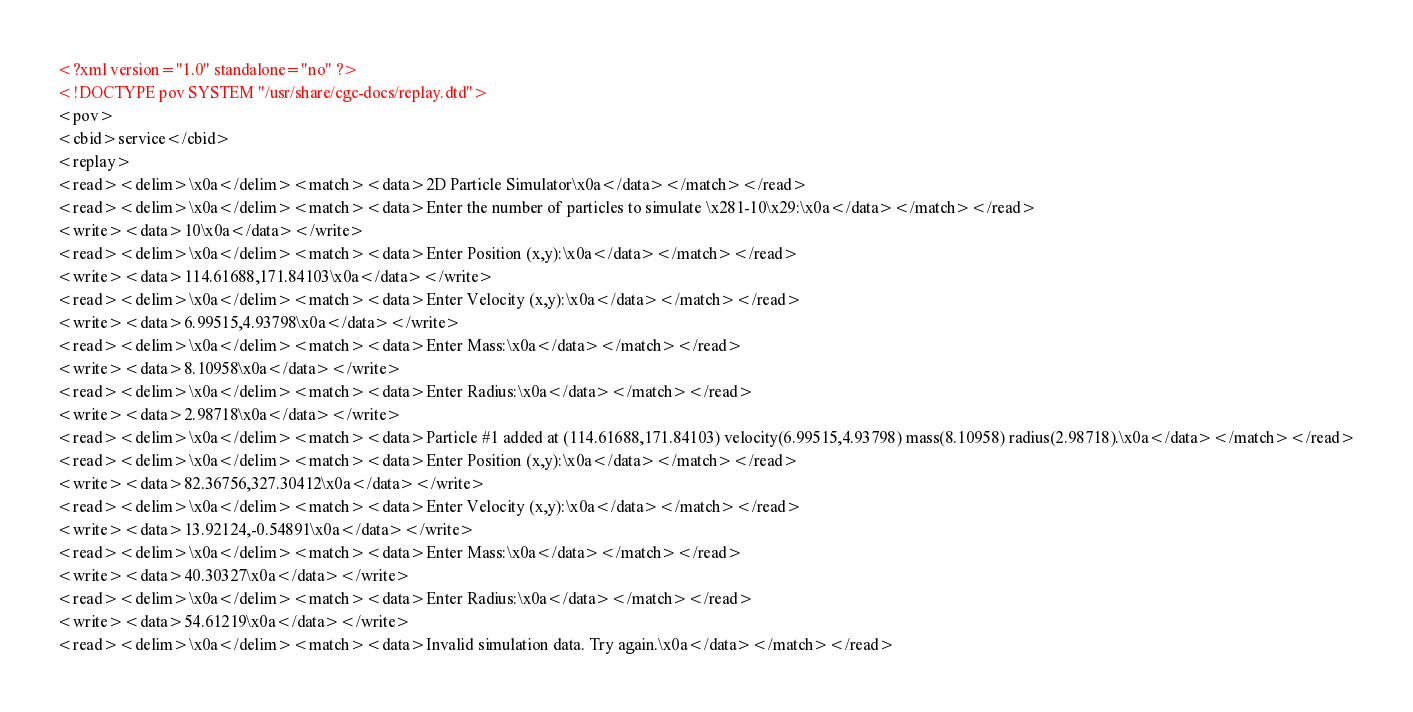Convert code to text. <code><loc_0><loc_0><loc_500><loc_500><_XML_><?xml version="1.0" standalone="no" ?>
<!DOCTYPE pov SYSTEM "/usr/share/cgc-docs/replay.dtd">
<pov>
<cbid>service</cbid>
<replay>
<read><delim>\x0a</delim><match><data>2D Particle Simulator\x0a</data></match></read>
<read><delim>\x0a</delim><match><data>Enter the number of particles to simulate \x281-10\x29:\x0a</data></match></read>
<write><data>10\x0a</data></write>
<read><delim>\x0a</delim><match><data>Enter Position (x,y):\x0a</data></match></read>
<write><data>114.61688,171.84103\x0a</data></write>
<read><delim>\x0a</delim><match><data>Enter Velocity (x,y):\x0a</data></match></read>
<write><data>6.99515,4.93798\x0a</data></write>
<read><delim>\x0a</delim><match><data>Enter Mass:\x0a</data></match></read>
<write><data>8.10958\x0a</data></write>
<read><delim>\x0a</delim><match><data>Enter Radius:\x0a</data></match></read>
<write><data>2.98718\x0a</data></write>
<read><delim>\x0a</delim><match><data>Particle #1 added at (114.61688,171.84103) velocity(6.99515,4.93798) mass(8.10958) radius(2.98718).\x0a</data></match></read>
<read><delim>\x0a</delim><match><data>Enter Position (x,y):\x0a</data></match></read>
<write><data>82.36756,327.30412\x0a</data></write>
<read><delim>\x0a</delim><match><data>Enter Velocity (x,y):\x0a</data></match></read>
<write><data>13.92124,-0.54891\x0a</data></write>
<read><delim>\x0a</delim><match><data>Enter Mass:\x0a</data></match></read>
<write><data>40.30327\x0a</data></write>
<read><delim>\x0a</delim><match><data>Enter Radius:\x0a</data></match></read>
<write><data>54.61219\x0a</data></write>
<read><delim>\x0a</delim><match><data>Invalid simulation data. Try again.\x0a</data></match></read></code> 